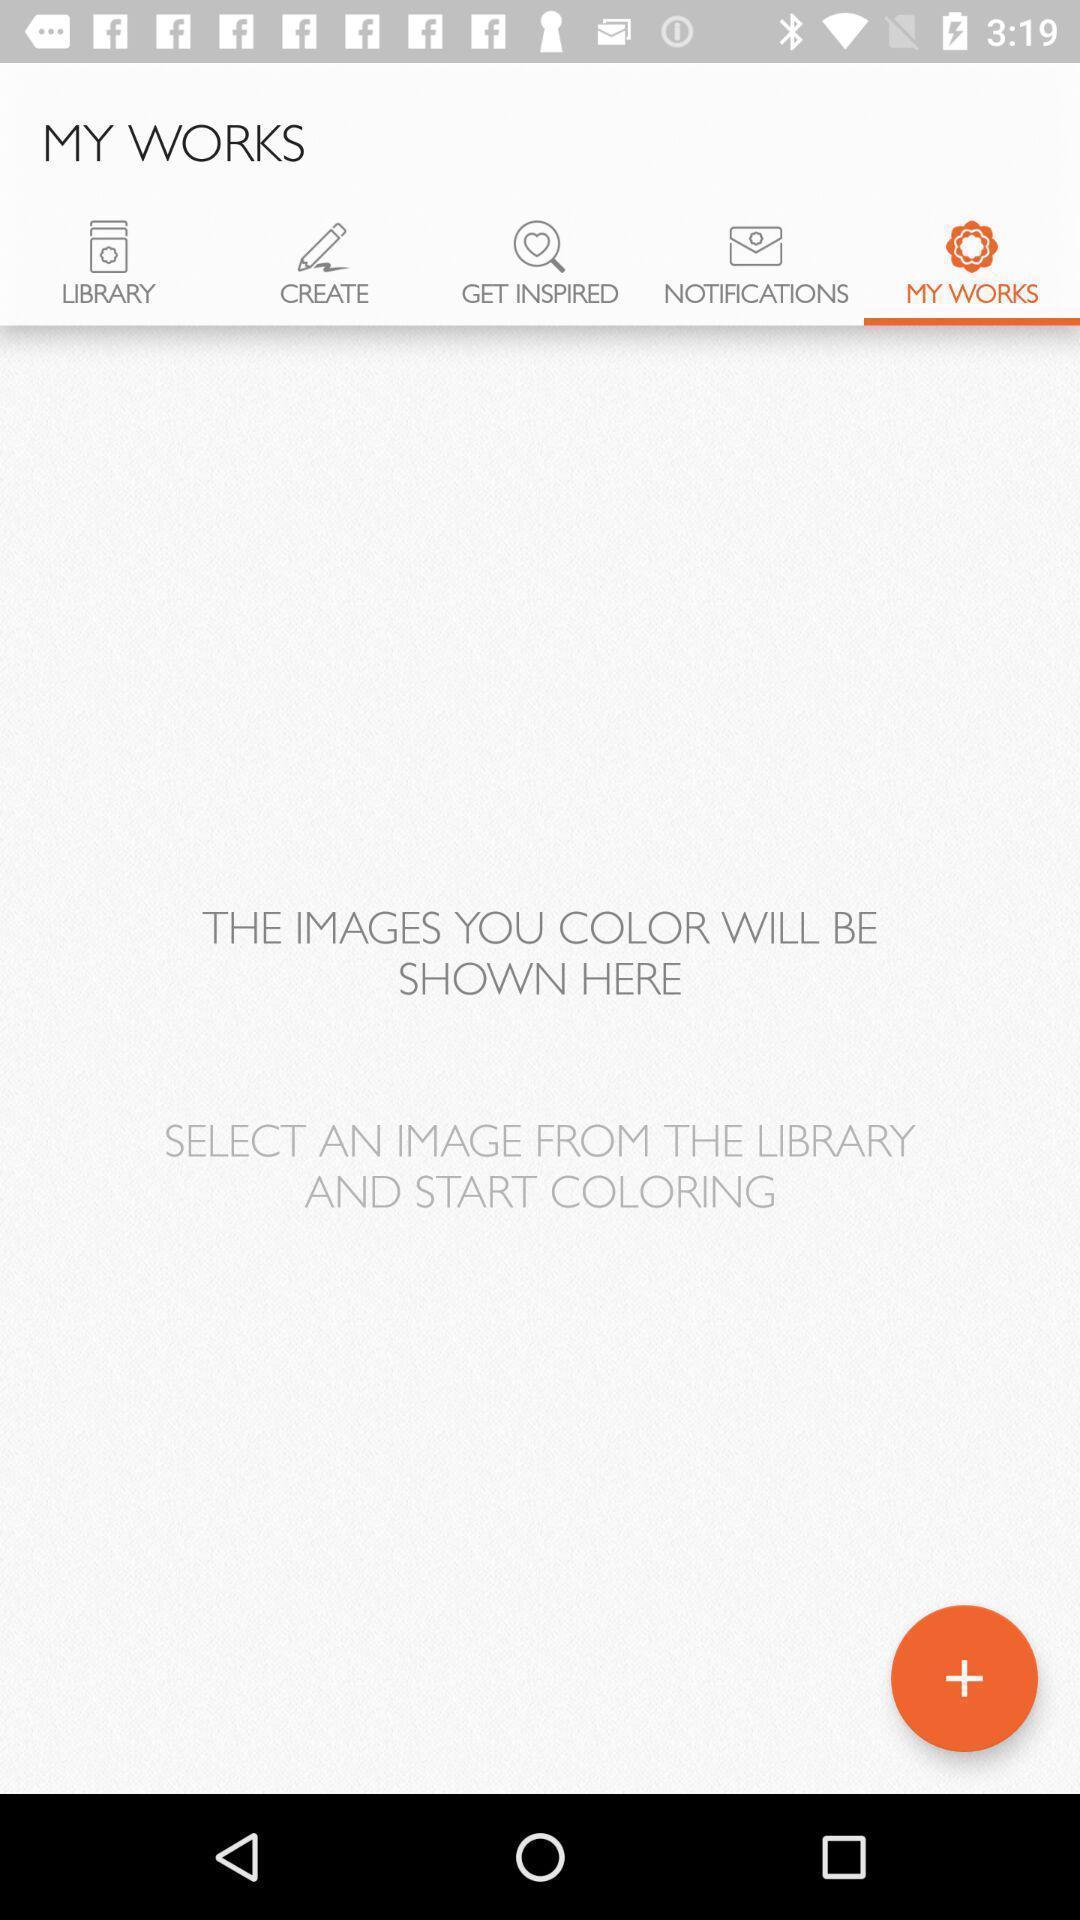Tell me about the visual elements in this screen capture. Page displays to select image in library in app. 